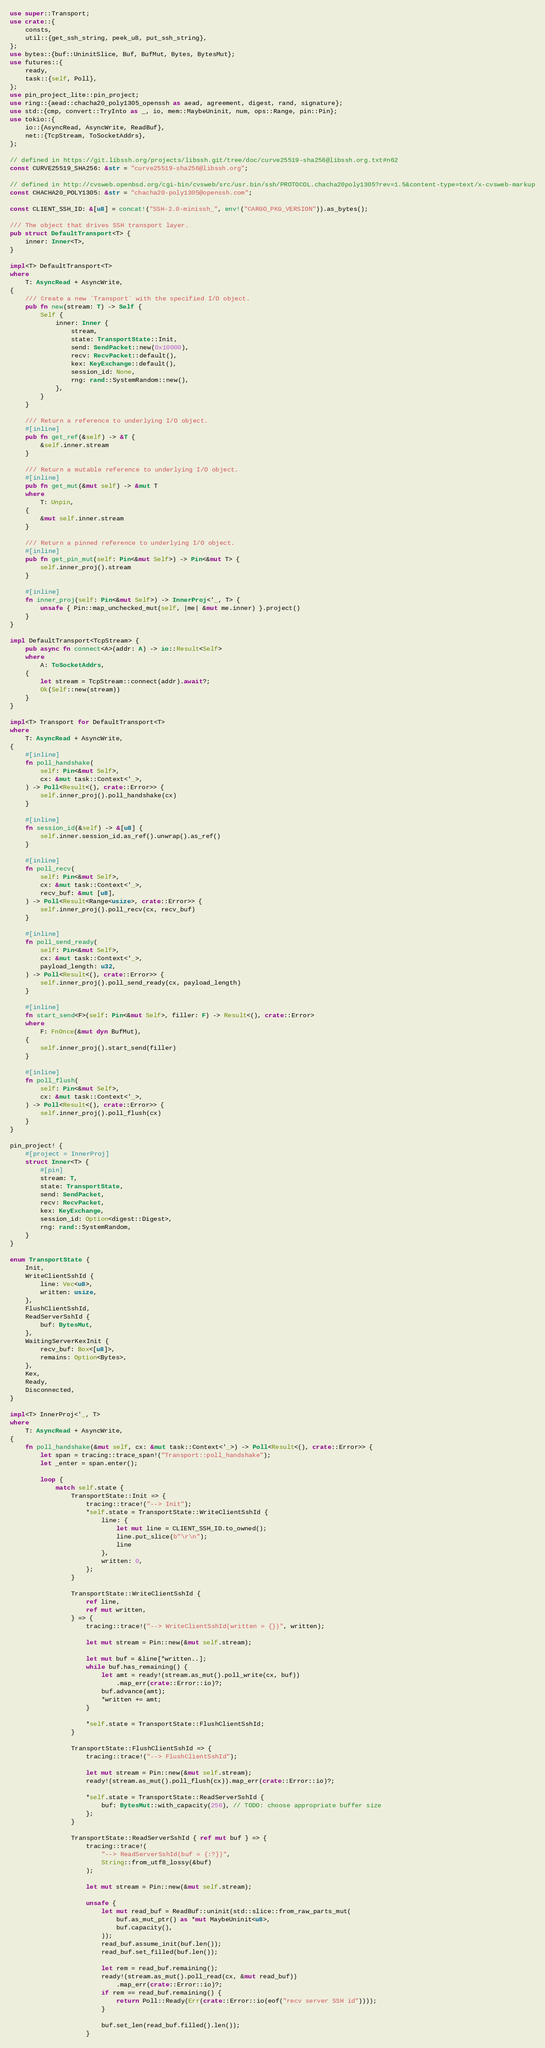Convert code to text. <code><loc_0><loc_0><loc_500><loc_500><_Rust_>use super::Transport;
use crate::{
    consts,
    util::{get_ssh_string, peek_u8, put_ssh_string},
};
use bytes::{buf::UninitSlice, Buf, BufMut, Bytes, BytesMut};
use futures::{
    ready,
    task::{self, Poll},
};
use pin_project_lite::pin_project;
use ring::{aead::chacha20_poly1305_openssh as aead, agreement, digest, rand, signature};
use std::{cmp, convert::TryInto as _, io, mem::MaybeUninit, num, ops::Range, pin::Pin};
use tokio::{
    io::{AsyncRead, AsyncWrite, ReadBuf},
    net::{TcpStream, ToSocketAddrs},
};

// defined in https://git.libssh.org/projects/libssh.git/tree/doc/curve25519-sha256@libssh.org.txt#n62
const CURVE25519_SHA256: &str = "curve25519-sha256@libssh.org";

// defined in http://cvsweb.openbsd.org/cgi-bin/cvsweb/src/usr.bin/ssh/PROTOCOL.chacha20poly1305?rev=1.5&content-type=text/x-cvsweb-markup
const CHACHA20_POLY1305: &str = "chacha20-poly1305@openssh.com";

const CLIENT_SSH_ID: &[u8] = concat!("SSH-2.0-minissh_", env!("CARGO_PKG_VERSION")).as_bytes();

/// The object that drives SSH transport layer.
pub struct DefaultTransport<T> {
    inner: Inner<T>,
}

impl<T> DefaultTransport<T>
where
    T: AsyncRead + AsyncWrite,
{
    /// Create a new `Transport` with the specified I/O object.
    pub fn new(stream: T) -> Self {
        Self {
            inner: Inner {
                stream,
                state: TransportState::Init,
                send: SendPacket::new(0x10000),
                recv: RecvPacket::default(),
                kex: KeyExchange::default(),
                session_id: None,
                rng: rand::SystemRandom::new(),
            },
        }
    }

    /// Return a reference to underlying I/O object.
    #[inline]
    pub fn get_ref(&self) -> &T {
        &self.inner.stream
    }

    /// Return a mutable reference to underlying I/O object.
    #[inline]
    pub fn get_mut(&mut self) -> &mut T
    where
        T: Unpin,
    {
        &mut self.inner.stream
    }

    /// Return a pinned reference to underlying I/O object.
    #[inline]
    pub fn get_pin_mut(self: Pin<&mut Self>) -> Pin<&mut T> {
        self.inner_proj().stream
    }

    #[inline]
    fn inner_proj(self: Pin<&mut Self>) -> InnerProj<'_, T> {
        unsafe { Pin::map_unchecked_mut(self, |me| &mut me.inner) }.project()
    }
}

impl DefaultTransport<TcpStream> {
    pub async fn connect<A>(addr: A) -> io::Result<Self>
    where
        A: ToSocketAddrs,
    {
        let stream = TcpStream::connect(addr).await?;
        Ok(Self::new(stream))
    }
}

impl<T> Transport for DefaultTransport<T>
where
    T: AsyncRead + AsyncWrite,
{
    #[inline]
    fn poll_handshake(
        self: Pin<&mut Self>,
        cx: &mut task::Context<'_>,
    ) -> Poll<Result<(), crate::Error>> {
        self.inner_proj().poll_handshake(cx)
    }

    #[inline]
    fn session_id(&self) -> &[u8] {
        self.inner.session_id.as_ref().unwrap().as_ref()
    }

    #[inline]
    fn poll_recv(
        self: Pin<&mut Self>,
        cx: &mut task::Context<'_>,
        recv_buf: &mut [u8],
    ) -> Poll<Result<Range<usize>, crate::Error>> {
        self.inner_proj().poll_recv(cx, recv_buf)
    }

    #[inline]
    fn poll_send_ready(
        self: Pin<&mut Self>,
        cx: &mut task::Context<'_>,
        payload_length: u32,
    ) -> Poll<Result<(), crate::Error>> {
        self.inner_proj().poll_send_ready(cx, payload_length)
    }

    #[inline]
    fn start_send<F>(self: Pin<&mut Self>, filler: F) -> Result<(), crate::Error>
    where
        F: FnOnce(&mut dyn BufMut),
    {
        self.inner_proj().start_send(filler)
    }

    #[inline]
    fn poll_flush(
        self: Pin<&mut Self>,
        cx: &mut task::Context<'_>,
    ) -> Poll<Result<(), crate::Error>> {
        self.inner_proj().poll_flush(cx)
    }
}

pin_project! {
    #[project = InnerProj]
    struct Inner<T> {
        #[pin]
        stream: T,
        state: TransportState,
        send: SendPacket,
        recv: RecvPacket,
        kex: KeyExchange,
        session_id: Option<digest::Digest>,
        rng: rand::SystemRandom,
    }
}

enum TransportState {
    Init,
    WriteClientSshId {
        line: Vec<u8>,
        written: usize,
    },
    FlushClientSshId,
    ReadServerSshId {
        buf: BytesMut,
    },
    WaitingServerKexInit {
        recv_buf: Box<[u8]>,
        remains: Option<Bytes>,
    },
    Kex,
    Ready,
    Disconnected,
}

impl<T> InnerProj<'_, T>
where
    T: AsyncRead + AsyncWrite,
{
    fn poll_handshake(&mut self, cx: &mut task::Context<'_>) -> Poll<Result<(), crate::Error>> {
        let span = tracing::trace_span!("Transport::poll_handshake");
        let _enter = span.enter();

        loop {
            match self.state {
                TransportState::Init => {
                    tracing::trace!("--> Init");
                    *self.state = TransportState::WriteClientSshId {
                        line: {
                            let mut line = CLIENT_SSH_ID.to_owned();
                            line.put_slice(b"\r\n");
                            line
                        },
                        written: 0,
                    };
                }

                TransportState::WriteClientSshId {
                    ref line,
                    ref mut written,
                } => {
                    tracing::trace!("--> WriteClientSshId(written = {})", written);

                    let mut stream = Pin::new(&mut self.stream);

                    let mut buf = &line[*written..];
                    while buf.has_remaining() {
                        let amt = ready!(stream.as_mut().poll_write(cx, buf))
                            .map_err(crate::Error::io)?;
                        buf.advance(amt);
                        *written += amt;
                    }

                    *self.state = TransportState::FlushClientSshId;
                }

                TransportState::FlushClientSshId => {
                    tracing::trace!("--> FlushClientSshId");

                    let mut stream = Pin::new(&mut self.stream);
                    ready!(stream.as_mut().poll_flush(cx)).map_err(crate::Error::io)?;

                    *self.state = TransportState::ReadServerSshId {
                        buf: BytesMut::with_capacity(256), // TODO: choose appropriate buffer size
                    };
                }

                TransportState::ReadServerSshId { ref mut buf } => {
                    tracing::trace!(
                        "--> ReadServerSshId(buf = {:?})",
                        String::from_utf8_lossy(&buf)
                    );

                    let mut stream = Pin::new(&mut self.stream);

                    unsafe {
                        let mut read_buf = ReadBuf::uninit(std::slice::from_raw_parts_mut(
                            buf.as_mut_ptr() as *mut MaybeUninit<u8>,
                            buf.capacity(),
                        ));
                        read_buf.assume_init(buf.len());
                        read_buf.set_filled(buf.len());

                        let rem = read_buf.remaining();
                        ready!(stream.as_mut().poll_read(cx, &mut read_buf))
                            .map_err(crate::Error::io)?;
                        if rem == read_buf.remaining() {
                            return Poll::Ready(Err(crate::Error::io(eof("recv server SSH id"))));
                        }

                        buf.set_len(read_buf.filled().len());
                    }
</code> 